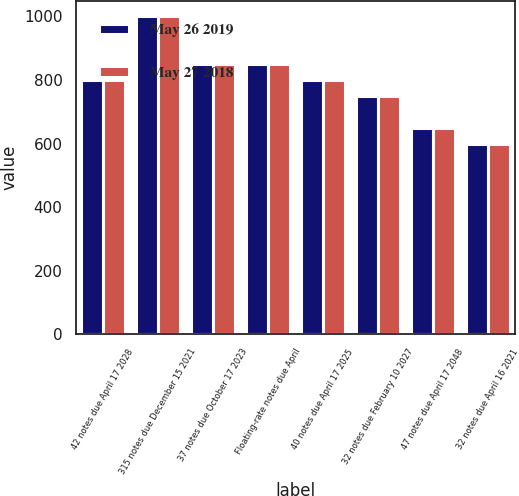Convert chart. <chart><loc_0><loc_0><loc_500><loc_500><stacked_bar_chart><ecel><fcel>42 notes due April 17 2028<fcel>315 notes due December 15 2021<fcel>37 notes due October 17 2023<fcel>Floating-rate notes due April<fcel>40 notes due April 17 2025<fcel>32 notes due February 10 2027<fcel>47 notes due April 17 2048<fcel>32 notes due April 16 2021<nl><fcel>May 26 2019<fcel>800<fcel>1000<fcel>850<fcel>850<fcel>800<fcel>750<fcel>650<fcel>600<nl><fcel>May 27 2018<fcel>800<fcel>1000<fcel>850<fcel>850<fcel>800<fcel>750<fcel>650<fcel>600<nl></chart> 